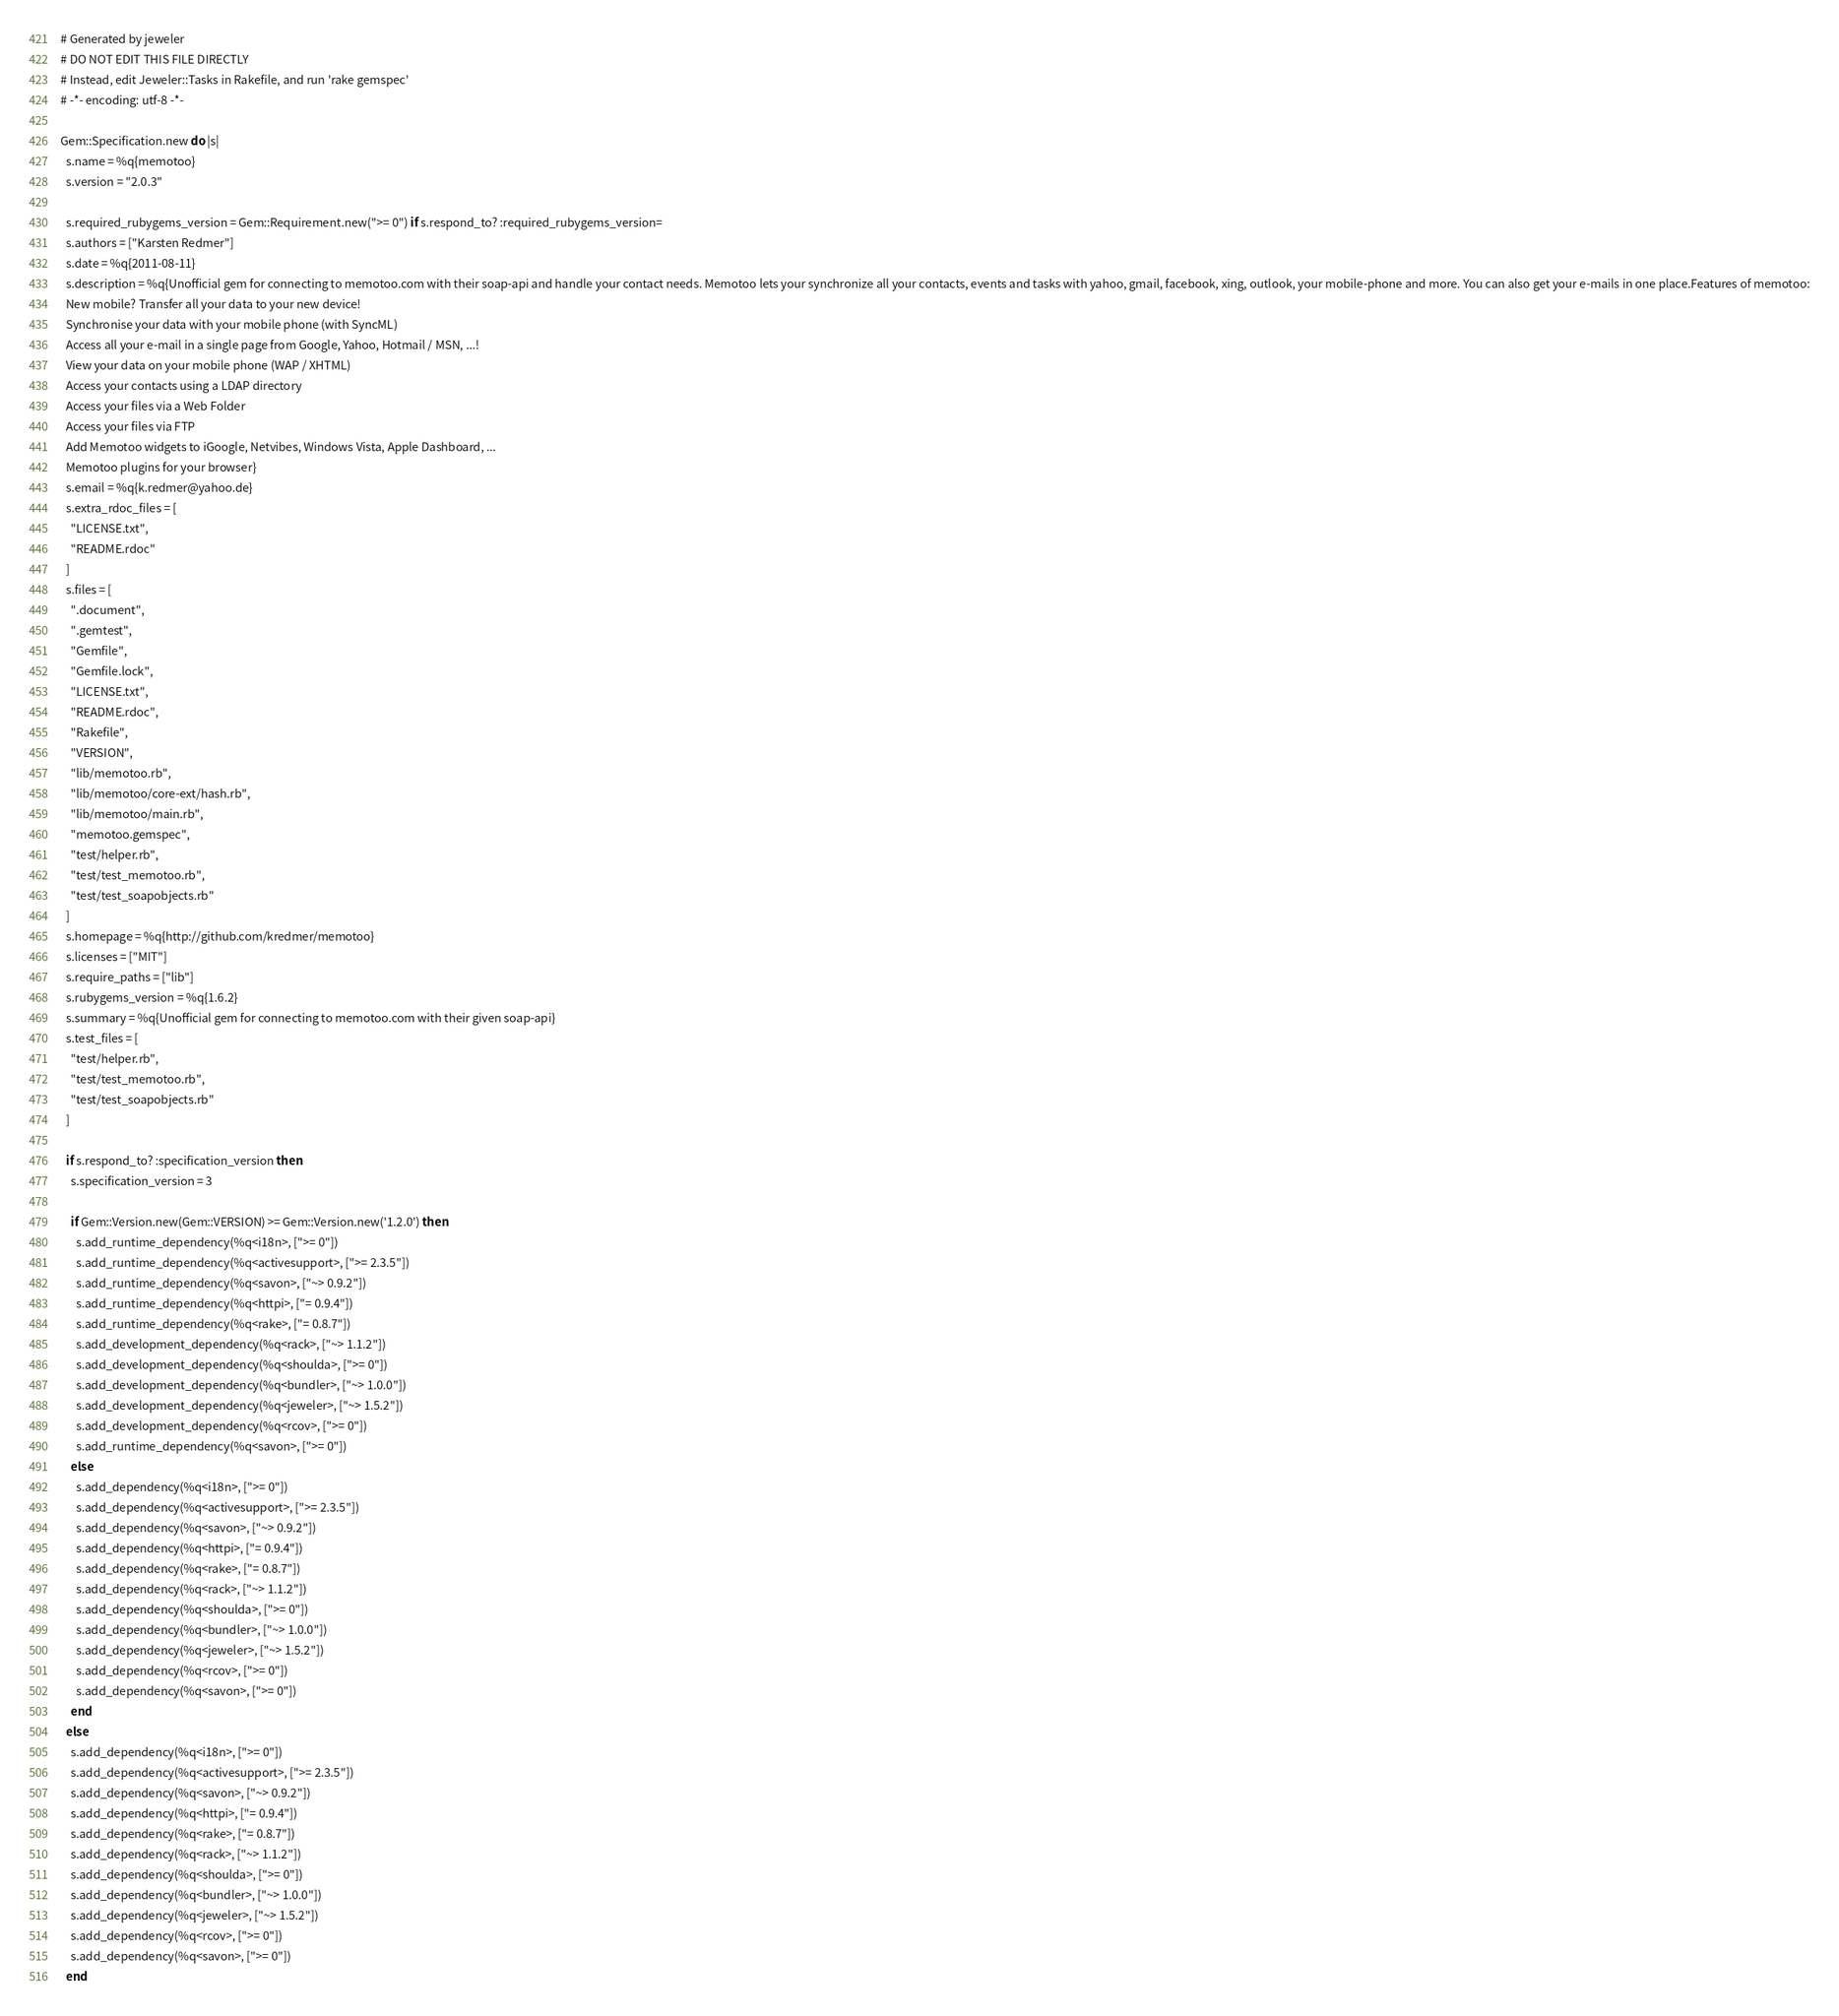<code> <loc_0><loc_0><loc_500><loc_500><_Ruby_># Generated by jeweler
# DO NOT EDIT THIS FILE DIRECTLY
# Instead, edit Jeweler::Tasks in Rakefile, and run 'rake gemspec'
# -*- encoding: utf-8 -*-

Gem::Specification.new do |s|
  s.name = %q{memotoo}
  s.version = "2.0.3"

  s.required_rubygems_version = Gem::Requirement.new(">= 0") if s.respond_to? :required_rubygems_version=
  s.authors = ["Karsten Redmer"]
  s.date = %q{2011-08-11}
  s.description = %q{Unofficial gem for connecting to memotoo.com with their soap-api and handle your contact needs. Memotoo lets your synchronize all your contacts, events and tasks with yahoo, gmail, facebook, xing, outlook, your mobile-phone and more. You can also get your e-mails in one place.Features of memotoo:
  New mobile? Transfer all your data to your new device!
  Synchronise your data with your mobile phone (with SyncML)
  Access all your e-mail in a single page from Google, Yahoo, Hotmail / MSN, ...!
  View your data on your mobile phone (WAP / XHTML)
  Access your contacts using a LDAP directory
  Access your files via a Web Folder
  Access your files via FTP
  Add Memotoo widgets to iGoogle, Netvibes, Windows Vista, Apple Dashboard, ...
  Memotoo plugins for your browser}
  s.email = %q{k.redmer@yahoo.de}
  s.extra_rdoc_files = [
    "LICENSE.txt",
    "README.rdoc"
  ]
  s.files = [
    ".document",
    ".gemtest",
    "Gemfile",
    "Gemfile.lock",
    "LICENSE.txt",
    "README.rdoc",
    "Rakefile",
    "VERSION",
    "lib/memotoo.rb",
    "lib/memotoo/core-ext/hash.rb",
    "lib/memotoo/main.rb",
    "memotoo.gemspec",
    "test/helper.rb",
    "test/test_memotoo.rb",
    "test/test_soapobjects.rb"
  ]
  s.homepage = %q{http://github.com/kredmer/memotoo}
  s.licenses = ["MIT"]
  s.require_paths = ["lib"]
  s.rubygems_version = %q{1.6.2}
  s.summary = %q{Unofficial gem for connecting to memotoo.com with their given soap-api}
  s.test_files = [
    "test/helper.rb",
    "test/test_memotoo.rb",
    "test/test_soapobjects.rb"
  ]

  if s.respond_to? :specification_version then
    s.specification_version = 3

    if Gem::Version.new(Gem::VERSION) >= Gem::Version.new('1.2.0') then
      s.add_runtime_dependency(%q<i18n>, [">= 0"])
      s.add_runtime_dependency(%q<activesupport>, [">= 2.3.5"])
      s.add_runtime_dependency(%q<savon>, ["~> 0.9.2"])
      s.add_runtime_dependency(%q<httpi>, ["= 0.9.4"])
      s.add_runtime_dependency(%q<rake>, ["= 0.8.7"])
      s.add_development_dependency(%q<rack>, ["~> 1.1.2"])
      s.add_development_dependency(%q<shoulda>, [">= 0"])
      s.add_development_dependency(%q<bundler>, ["~> 1.0.0"])
      s.add_development_dependency(%q<jeweler>, ["~> 1.5.2"])
      s.add_development_dependency(%q<rcov>, [">= 0"])
      s.add_runtime_dependency(%q<savon>, [">= 0"])
    else
      s.add_dependency(%q<i18n>, [">= 0"])
      s.add_dependency(%q<activesupport>, [">= 2.3.5"])
      s.add_dependency(%q<savon>, ["~> 0.9.2"])
      s.add_dependency(%q<httpi>, ["= 0.9.4"])
      s.add_dependency(%q<rake>, ["= 0.8.7"])
      s.add_dependency(%q<rack>, ["~> 1.1.2"])
      s.add_dependency(%q<shoulda>, [">= 0"])
      s.add_dependency(%q<bundler>, ["~> 1.0.0"])
      s.add_dependency(%q<jeweler>, ["~> 1.5.2"])
      s.add_dependency(%q<rcov>, [">= 0"])
      s.add_dependency(%q<savon>, [">= 0"])
    end
  else
    s.add_dependency(%q<i18n>, [">= 0"])
    s.add_dependency(%q<activesupport>, [">= 2.3.5"])
    s.add_dependency(%q<savon>, ["~> 0.9.2"])
    s.add_dependency(%q<httpi>, ["= 0.9.4"])
    s.add_dependency(%q<rake>, ["= 0.8.7"])
    s.add_dependency(%q<rack>, ["~> 1.1.2"])
    s.add_dependency(%q<shoulda>, [">= 0"])
    s.add_dependency(%q<bundler>, ["~> 1.0.0"])
    s.add_dependency(%q<jeweler>, ["~> 1.5.2"])
    s.add_dependency(%q<rcov>, [">= 0"])
    s.add_dependency(%q<savon>, [">= 0"])
  end</code> 